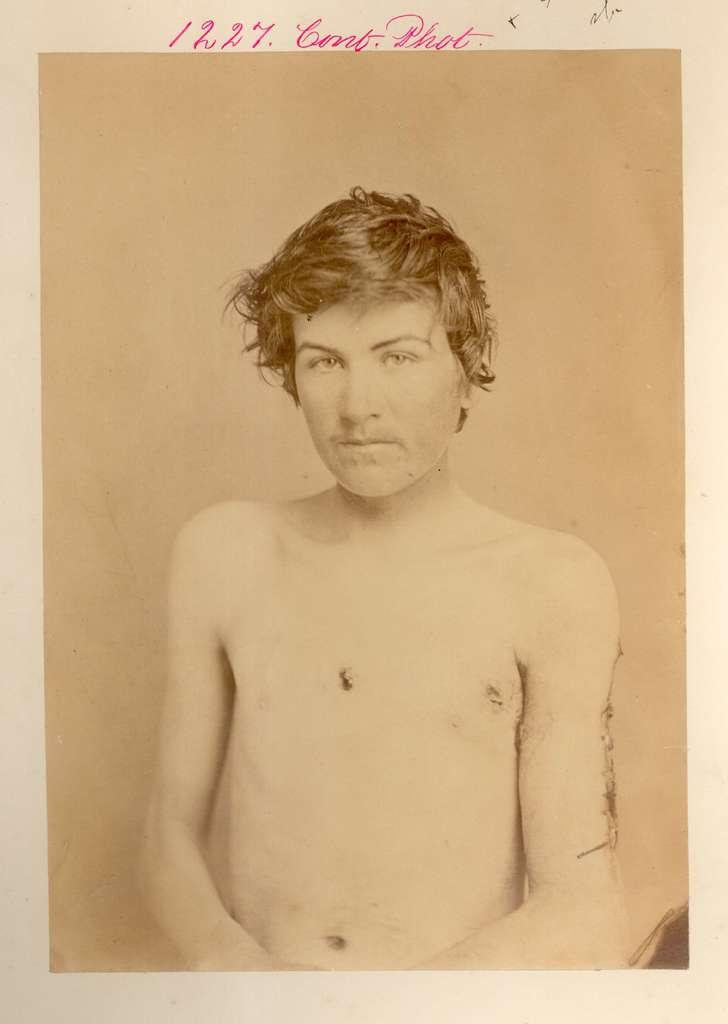What is featured on the poster in the image? There is a poster in the image, and it contains a man standing near a wall. Is there any additional information on the poster? Yes, there is a date visible on the poster. How many steps does the man take in the image? There is no indication of the man taking any steps in the image, as he is standing near a wall. What type of birthday celebration is depicted in the image? There is no birthday celebration depicted in the image; it only features a man standing near a wall on a poster. 